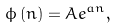Convert formula to latex. <formula><loc_0><loc_0><loc_500><loc_500>\phi \left ( n \right ) = A e ^ { a n } ,</formula> 